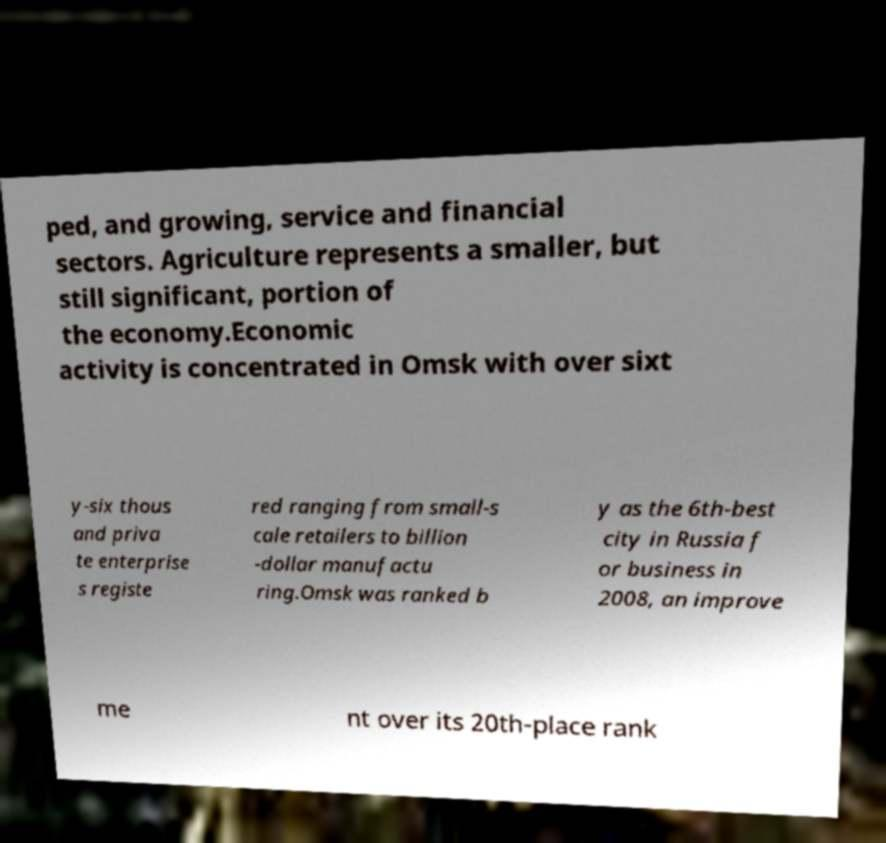There's text embedded in this image that I need extracted. Can you transcribe it verbatim? ped, and growing, service and financial sectors. Agriculture represents a smaller, but still significant, portion of the economy.Economic activity is concentrated in Omsk with over sixt y-six thous and priva te enterprise s registe red ranging from small-s cale retailers to billion -dollar manufactu ring.Omsk was ranked b y as the 6th-best city in Russia f or business in 2008, an improve me nt over its 20th-place rank 